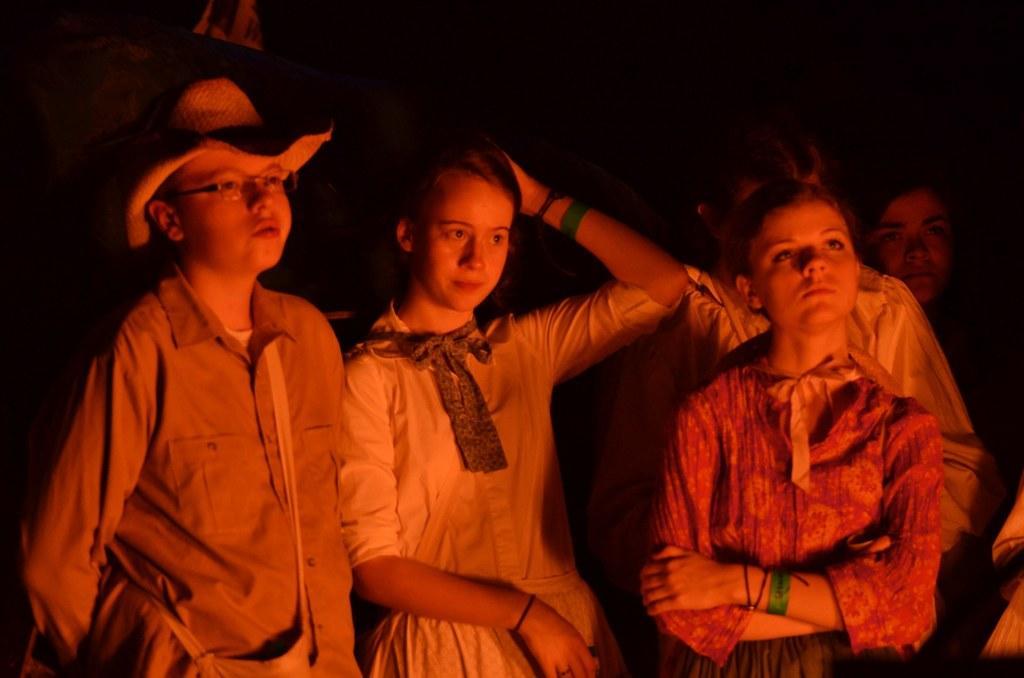Could you give a brief overview of what you see in this image? In this image we can see this person wearing shirt, spectacles and hat and these people are standing here. The background of the image is dark. 